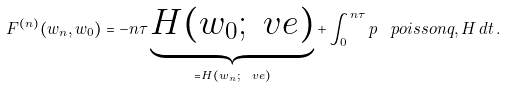<formula> <loc_0><loc_0><loc_500><loc_500>F ^ { ( n ) } ( w _ { n } , w _ { 0 } ) = - n \tau \underbrace { H ( w _ { 0 } ; \ v e ) } _ { = H ( w _ { n } ; \ v e ) } + \int _ { 0 } ^ { n \tau } p \, \ p o i s s o n { q , H } \, d t \, .</formula> 